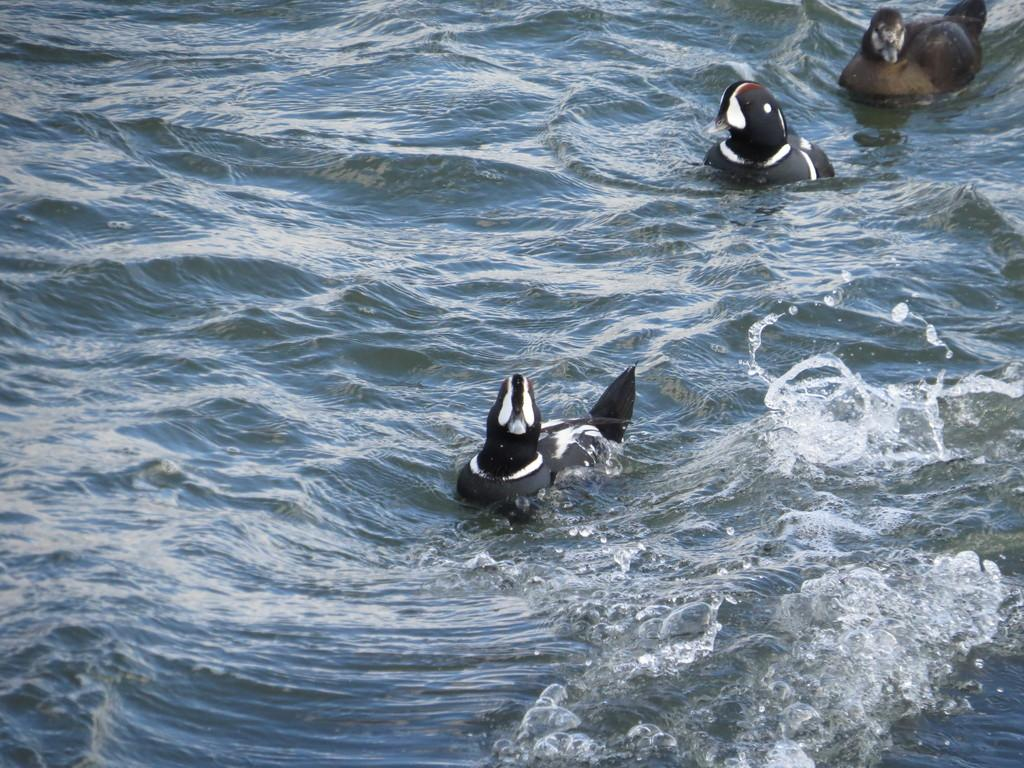What is the primary element in the image? There is water in the image. How many aquatic animals can be seen in the image? There are three aquatic animals in the image. What colors are the aquatic animals? The aquatic animals are white and black in color. What type of cap is the aquatic animal wearing in the image? There are no caps present in the image, as the aquatic animals are not wearing any clothing or accessories. 